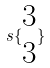<formula> <loc_0><loc_0><loc_500><loc_500>s \{ \begin{matrix} 3 \\ 3 \end{matrix} \}</formula> 